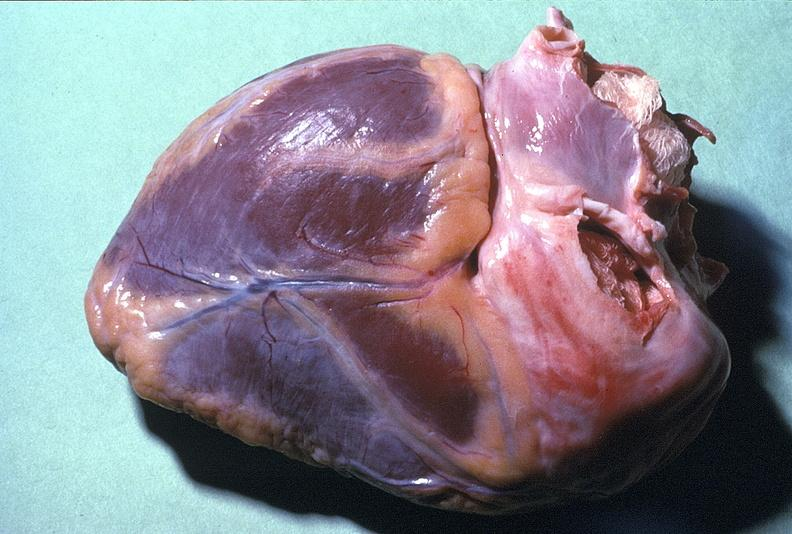does nodular tumor show normal duct in postmenopausal woman?
Answer the question using a single word or phrase. No 